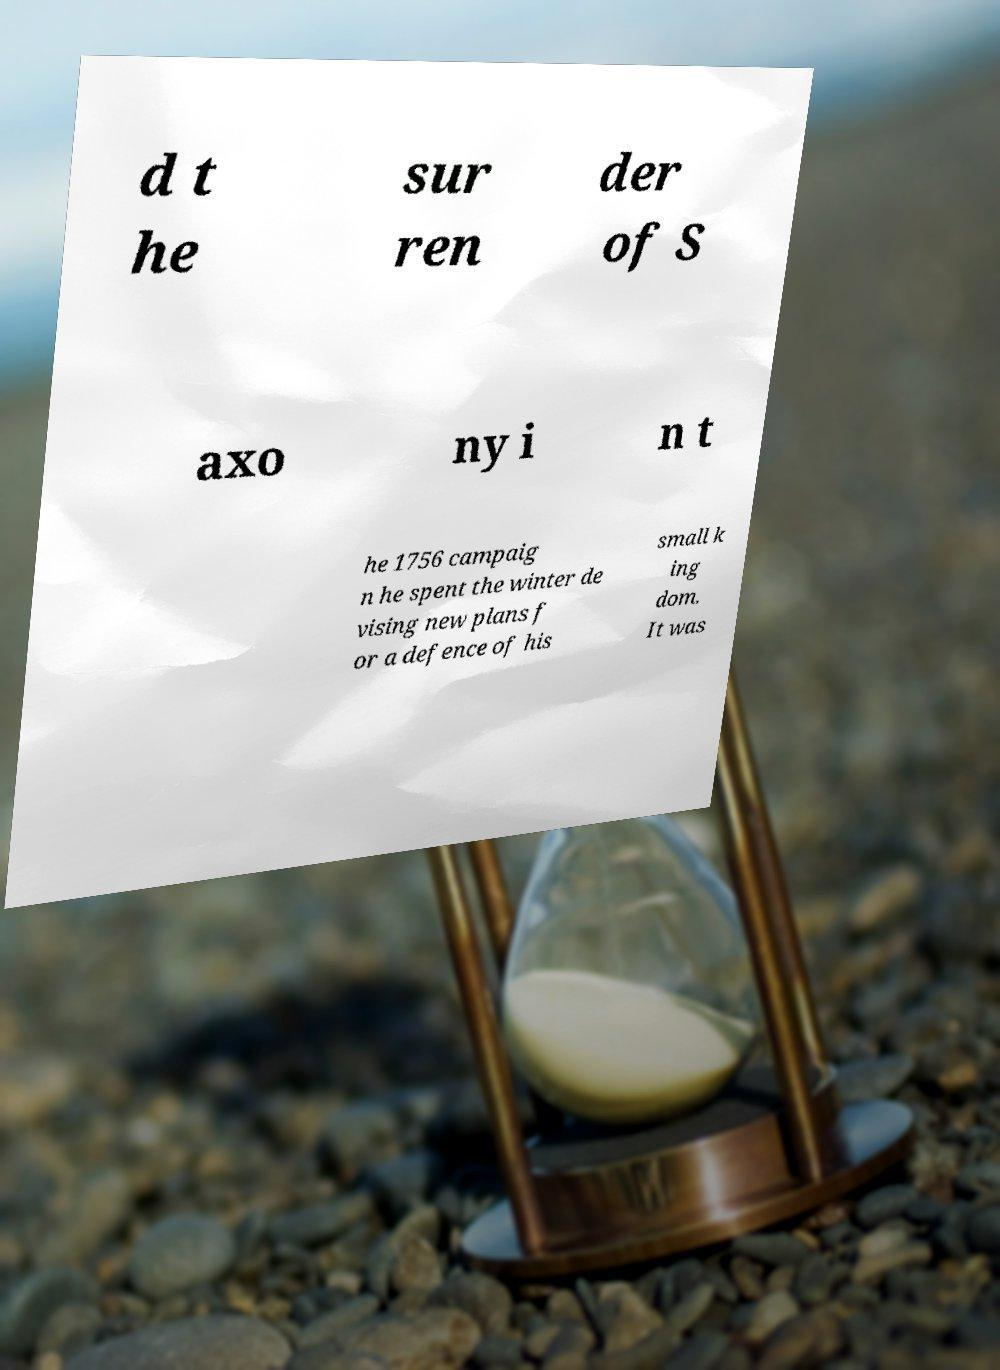Could you assist in decoding the text presented in this image and type it out clearly? d t he sur ren der of S axo ny i n t he 1756 campaig n he spent the winter de vising new plans f or a defence of his small k ing dom. It was 